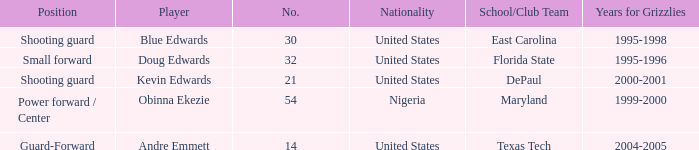What's the highest player number from the list from 2000-2001 21.0. 